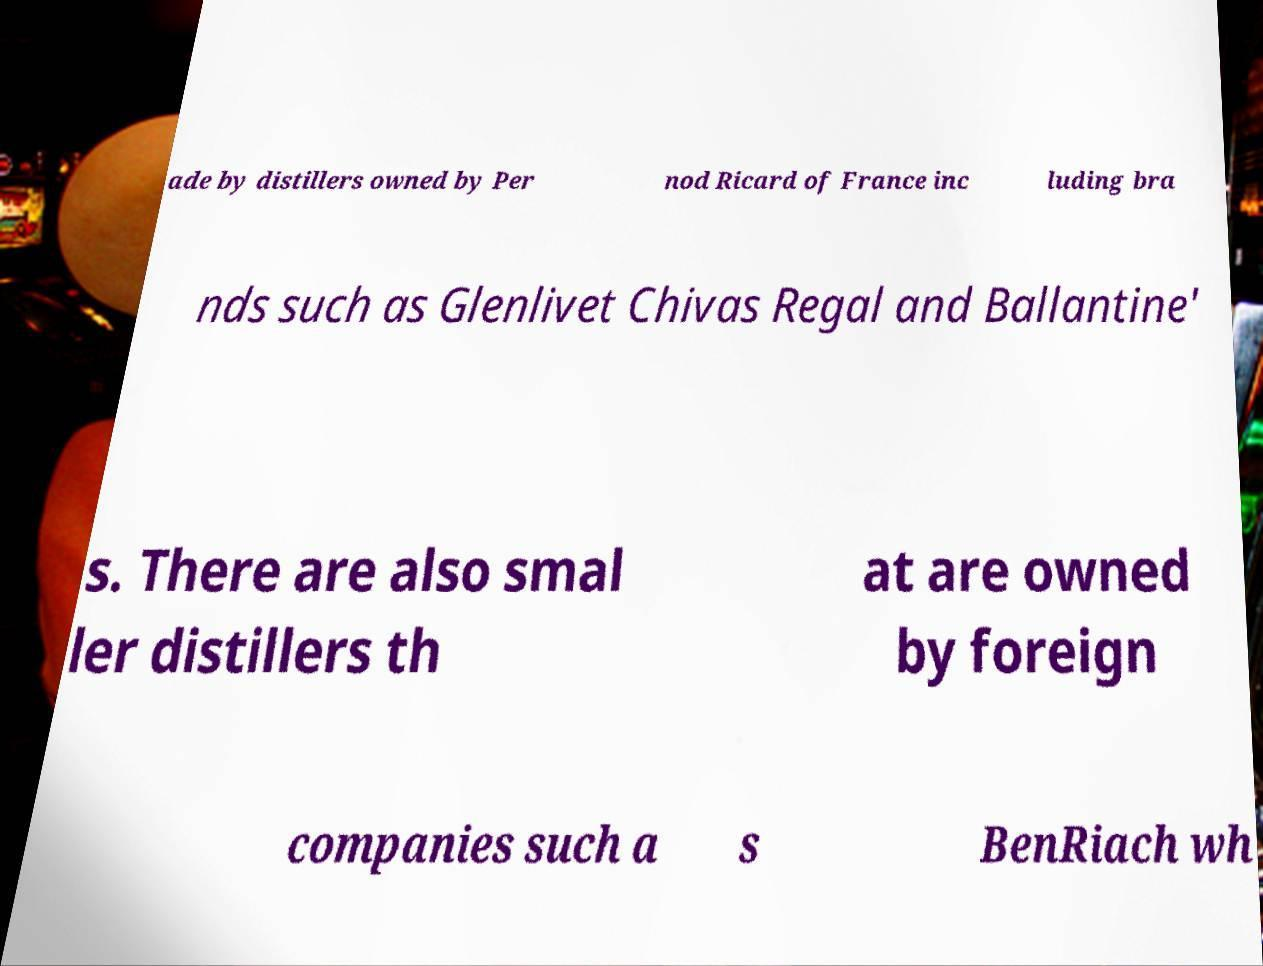What messages or text are displayed in this image? I need them in a readable, typed format. ade by distillers owned by Per nod Ricard of France inc luding bra nds such as Glenlivet Chivas Regal and Ballantine' s. There are also smal ler distillers th at are owned by foreign companies such a s BenRiach wh 